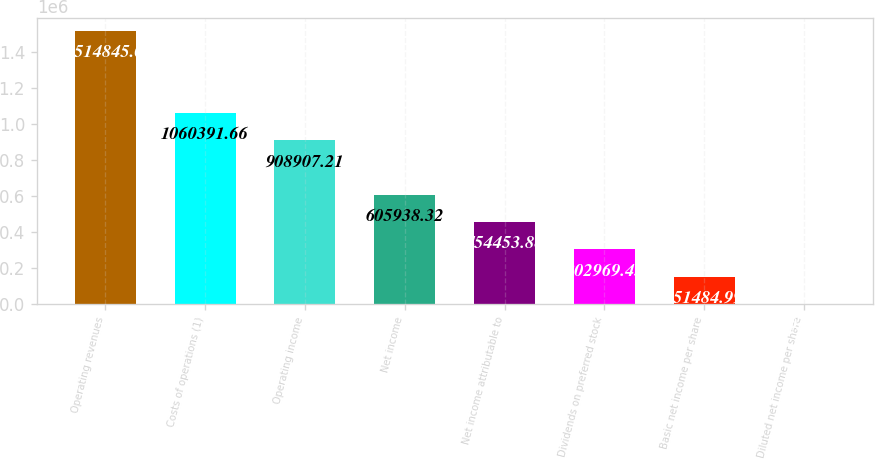Convert chart. <chart><loc_0><loc_0><loc_500><loc_500><bar_chart><fcel>Operating revenues<fcel>Costs of operations (1)<fcel>Operating income<fcel>Net income<fcel>Net income attributable to<fcel>Dividends on preferred stock<fcel>Basic net income per share<fcel>Diluted net income per share<nl><fcel>1.51484e+06<fcel>1.06039e+06<fcel>908907<fcel>605938<fcel>454454<fcel>302969<fcel>151485<fcel>0.55<nl></chart> 